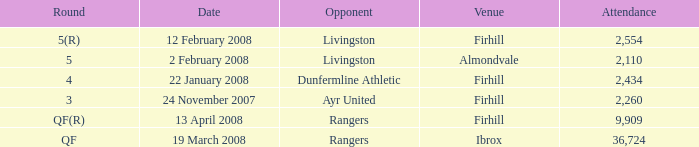What day was the game held at Firhill against AYR United? 24 November 2007. 